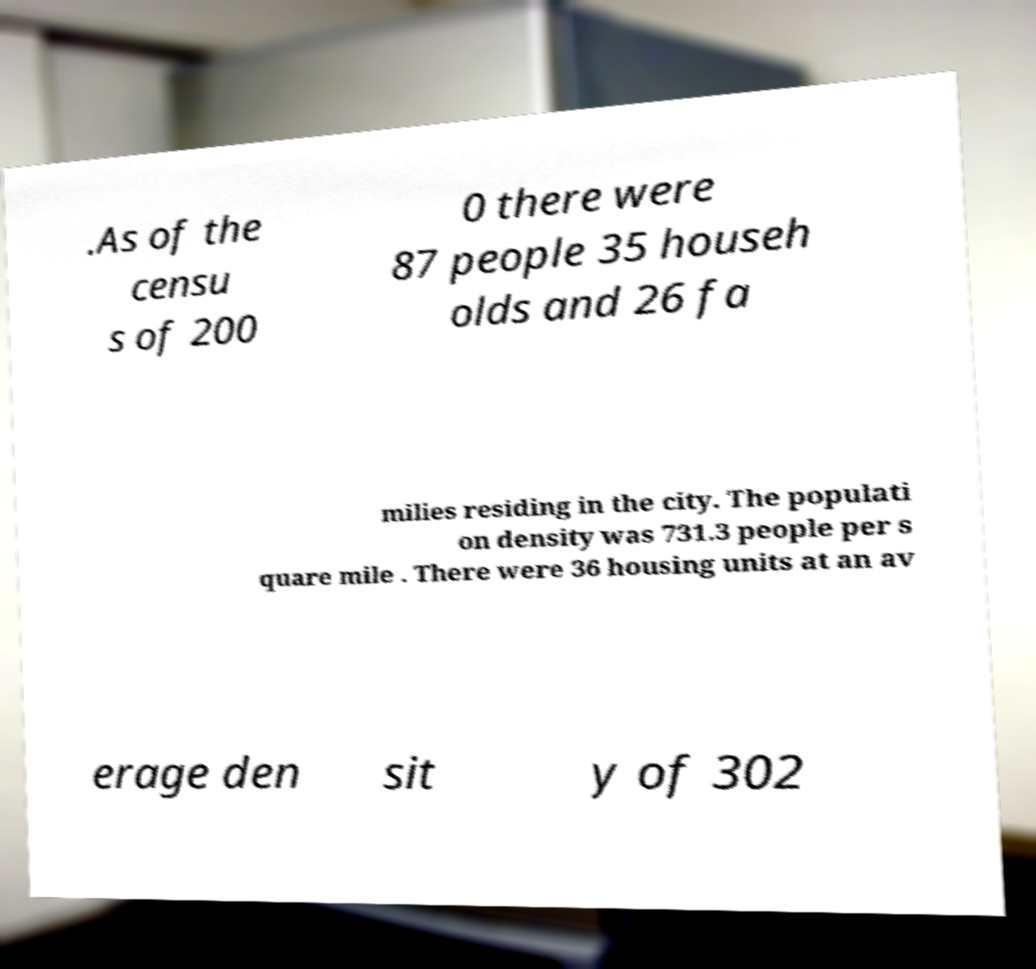Can you accurately transcribe the text from the provided image for me? .As of the censu s of 200 0 there were 87 people 35 househ olds and 26 fa milies residing in the city. The populati on density was 731.3 people per s quare mile . There were 36 housing units at an av erage den sit y of 302 